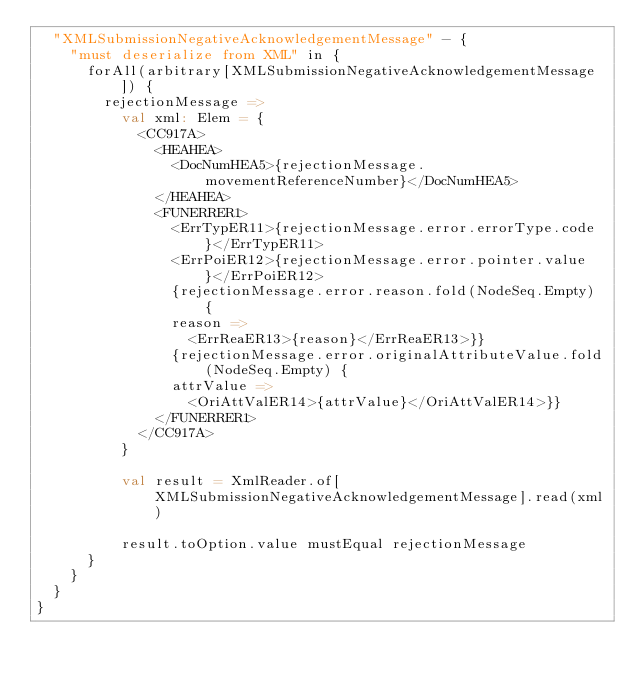Convert code to text. <code><loc_0><loc_0><loc_500><loc_500><_Scala_>  "XMLSubmissionNegativeAcknowledgementMessage" - {
    "must deserialize from XML" in {
      forAll(arbitrary[XMLSubmissionNegativeAcknowledgementMessage]) {
        rejectionMessage =>
          val xml: Elem = {
            <CC917A>
              <HEAHEA>
                <DocNumHEA5>{rejectionMessage.movementReferenceNumber}</DocNumHEA5>
              </HEAHEA>
              <FUNERRER1>
                <ErrTypER11>{rejectionMessage.error.errorType.code}</ErrTypER11>
                <ErrPoiER12>{rejectionMessage.error.pointer.value}</ErrPoiER12>
                {rejectionMessage.error.reason.fold(NodeSeq.Empty) {
                reason =>
                  <ErrReaER13>{reason}</ErrReaER13>}}
                {rejectionMessage.error.originalAttributeValue.fold(NodeSeq.Empty) {
                attrValue =>
                  <OriAttValER14>{attrValue}</OriAttValER14>}}
              </FUNERRER1>
            </CC917A>
          }

          val result = XmlReader.of[XMLSubmissionNegativeAcknowledgementMessage].read(xml)

          result.toOption.value mustEqual rejectionMessage
      }
    }
  }
}
</code> 